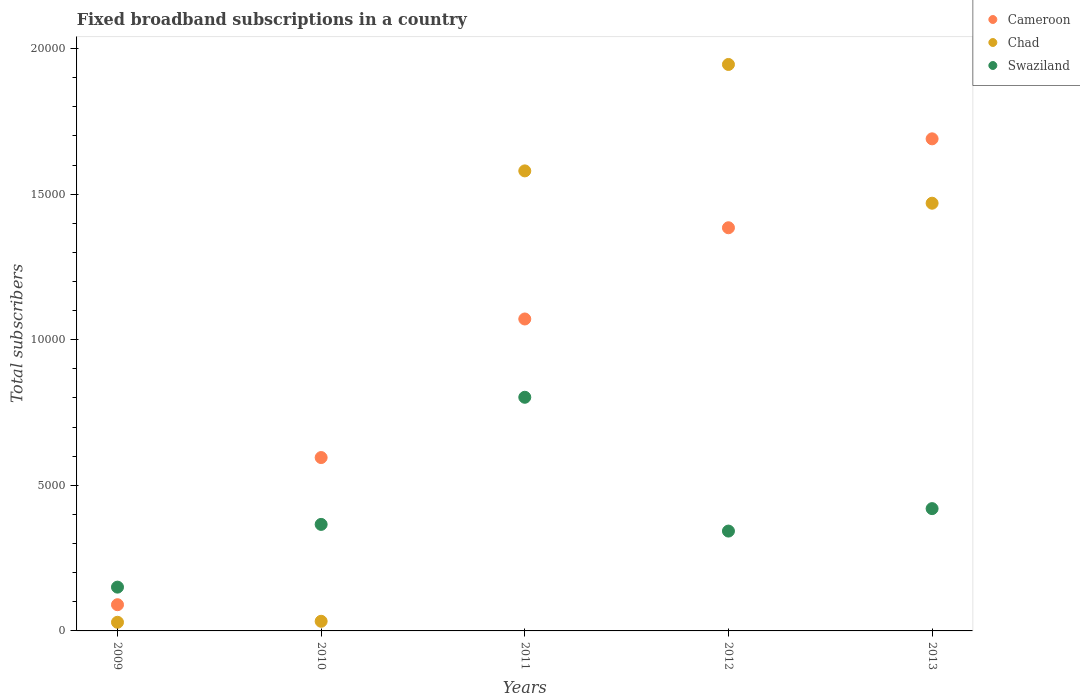How many different coloured dotlines are there?
Your response must be concise. 3. What is the number of broadband subscriptions in Swaziland in 2010?
Provide a succinct answer. 3658. Across all years, what is the maximum number of broadband subscriptions in Cameroon?
Make the answer very short. 1.69e+04. Across all years, what is the minimum number of broadband subscriptions in Chad?
Your response must be concise. 297. What is the total number of broadband subscriptions in Cameroon in the graph?
Keep it short and to the point. 4.83e+04. What is the difference between the number of broadband subscriptions in Swaziland in 2009 and that in 2013?
Provide a short and direct response. -2696. What is the difference between the number of broadband subscriptions in Chad in 2009 and the number of broadband subscriptions in Swaziland in 2012?
Offer a terse response. -3132. What is the average number of broadband subscriptions in Chad per year?
Offer a terse response. 1.01e+04. In the year 2011, what is the difference between the number of broadband subscriptions in Chad and number of broadband subscriptions in Swaziland?
Give a very brief answer. 7775. What is the ratio of the number of broadband subscriptions in Cameroon in 2011 to that in 2013?
Provide a succinct answer. 0.63. Is the number of broadband subscriptions in Swaziland in 2009 less than that in 2012?
Offer a terse response. Yes. What is the difference between the highest and the second highest number of broadband subscriptions in Swaziland?
Make the answer very short. 3824. What is the difference between the highest and the lowest number of broadband subscriptions in Cameroon?
Your answer should be very brief. 1.60e+04. In how many years, is the number of broadband subscriptions in Chad greater than the average number of broadband subscriptions in Chad taken over all years?
Offer a very short reply. 3. Is the sum of the number of broadband subscriptions in Cameroon in 2010 and 2013 greater than the maximum number of broadband subscriptions in Chad across all years?
Offer a terse response. Yes. Is it the case that in every year, the sum of the number of broadband subscriptions in Chad and number of broadband subscriptions in Cameroon  is greater than the number of broadband subscriptions in Swaziland?
Provide a short and direct response. No. Is the number of broadband subscriptions in Cameroon strictly greater than the number of broadband subscriptions in Chad over the years?
Offer a terse response. No. Is the number of broadband subscriptions in Chad strictly less than the number of broadband subscriptions in Swaziland over the years?
Make the answer very short. No. How many dotlines are there?
Offer a very short reply. 3. How many years are there in the graph?
Your answer should be compact. 5. Are the values on the major ticks of Y-axis written in scientific E-notation?
Give a very brief answer. No. Does the graph contain any zero values?
Provide a succinct answer. No. Does the graph contain grids?
Ensure brevity in your answer.  No. Where does the legend appear in the graph?
Your response must be concise. Top right. How many legend labels are there?
Ensure brevity in your answer.  3. What is the title of the graph?
Your answer should be compact. Fixed broadband subscriptions in a country. Does "Kosovo" appear as one of the legend labels in the graph?
Your response must be concise. No. What is the label or title of the X-axis?
Provide a short and direct response. Years. What is the label or title of the Y-axis?
Give a very brief answer. Total subscribers. What is the Total subscribers in Cameroon in 2009?
Offer a very short reply. 900. What is the Total subscribers of Chad in 2009?
Offer a terse response. 297. What is the Total subscribers of Swaziland in 2009?
Offer a very short reply. 1504. What is the Total subscribers of Cameroon in 2010?
Give a very brief answer. 5954. What is the Total subscribers in Chad in 2010?
Give a very brief answer. 331. What is the Total subscribers in Swaziland in 2010?
Provide a succinct answer. 3658. What is the Total subscribers of Cameroon in 2011?
Provide a short and direct response. 1.07e+04. What is the Total subscribers in Chad in 2011?
Provide a short and direct response. 1.58e+04. What is the Total subscribers in Swaziland in 2011?
Give a very brief answer. 8024. What is the Total subscribers in Cameroon in 2012?
Keep it short and to the point. 1.38e+04. What is the Total subscribers of Chad in 2012?
Your response must be concise. 1.95e+04. What is the Total subscribers in Swaziland in 2012?
Your response must be concise. 3429. What is the Total subscribers in Cameroon in 2013?
Make the answer very short. 1.69e+04. What is the Total subscribers in Chad in 2013?
Offer a very short reply. 1.47e+04. What is the Total subscribers of Swaziland in 2013?
Give a very brief answer. 4200. Across all years, what is the maximum Total subscribers of Cameroon?
Ensure brevity in your answer.  1.69e+04. Across all years, what is the maximum Total subscribers of Chad?
Give a very brief answer. 1.95e+04. Across all years, what is the maximum Total subscribers of Swaziland?
Provide a succinct answer. 8024. Across all years, what is the minimum Total subscribers of Cameroon?
Keep it short and to the point. 900. Across all years, what is the minimum Total subscribers in Chad?
Make the answer very short. 297. Across all years, what is the minimum Total subscribers in Swaziland?
Offer a terse response. 1504. What is the total Total subscribers of Cameroon in the graph?
Offer a terse response. 4.83e+04. What is the total Total subscribers of Chad in the graph?
Provide a short and direct response. 5.06e+04. What is the total Total subscribers of Swaziland in the graph?
Provide a short and direct response. 2.08e+04. What is the difference between the Total subscribers of Cameroon in 2009 and that in 2010?
Your answer should be very brief. -5054. What is the difference between the Total subscribers in Chad in 2009 and that in 2010?
Your answer should be compact. -34. What is the difference between the Total subscribers of Swaziland in 2009 and that in 2010?
Your response must be concise. -2154. What is the difference between the Total subscribers in Cameroon in 2009 and that in 2011?
Your response must be concise. -9813. What is the difference between the Total subscribers of Chad in 2009 and that in 2011?
Offer a terse response. -1.55e+04. What is the difference between the Total subscribers in Swaziland in 2009 and that in 2011?
Ensure brevity in your answer.  -6520. What is the difference between the Total subscribers in Cameroon in 2009 and that in 2012?
Your response must be concise. -1.29e+04. What is the difference between the Total subscribers in Chad in 2009 and that in 2012?
Your response must be concise. -1.92e+04. What is the difference between the Total subscribers in Swaziland in 2009 and that in 2012?
Make the answer very short. -1925. What is the difference between the Total subscribers of Cameroon in 2009 and that in 2013?
Offer a terse response. -1.60e+04. What is the difference between the Total subscribers of Chad in 2009 and that in 2013?
Ensure brevity in your answer.  -1.44e+04. What is the difference between the Total subscribers of Swaziland in 2009 and that in 2013?
Provide a succinct answer. -2696. What is the difference between the Total subscribers in Cameroon in 2010 and that in 2011?
Provide a succinct answer. -4759. What is the difference between the Total subscribers of Chad in 2010 and that in 2011?
Make the answer very short. -1.55e+04. What is the difference between the Total subscribers of Swaziland in 2010 and that in 2011?
Provide a succinct answer. -4366. What is the difference between the Total subscribers in Cameroon in 2010 and that in 2012?
Your response must be concise. -7892. What is the difference between the Total subscribers of Chad in 2010 and that in 2012?
Your answer should be compact. -1.91e+04. What is the difference between the Total subscribers of Swaziland in 2010 and that in 2012?
Offer a very short reply. 229. What is the difference between the Total subscribers of Cameroon in 2010 and that in 2013?
Provide a short and direct response. -1.09e+04. What is the difference between the Total subscribers of Chad in 2010 and that in 2013?
Offer a very short reply. -1.44e+04. What is the difference between the Total subscribers of Swaziland in 2010 and that in 2013?
Offer a terse response. -542. What is the difference between the Total subscribers in Cameroon in 2011 and that in 2012?
Provide a succinct answer. -3133. What is the difference between the Total subscribers of Chad in 2011 and that in 2012?
Offer a terse response. -3655. What is the difference between the Total subscribers in Swaziland in 2011 and that in 2012?
Make the answer very short. 4595. What is the difference between the Total subscribers in Cameroon in 2011 and that in 2013?
Your answer should be compact. -6187. What is the difference between the Total subscribers of Chad in 2011 and that in 2013?
Your answer should be compact. 1110. What is the difference between the Total subscribers in Swaziland in 2011 and that in 2013?
Your response must be concise. 3824. What is the difference between the Total subscribers of Cameroon in 2012 and that in 2013?
Your answer should be compact. -3054. What is the difference between the Total subscribers of Chad in 2012 and that in 2013?
Your response must be concise. 4765. What is the difference between the Total subscribers of Swaziland in 2012 and that in 2013?
Keep it short and to the point. -771. What is the difference between the Total subscribers of Cameroon in 2009 and the Total subscribers of Chad in 2010?
Give a very brief answer. 569. What is the difference between the Total subscribers of Cameroon in 2009 and the Total subscribers of Swaziland in 2010?
Your answer should be very brief. -2758. What is the difference between the Total subscribers of Chad in 2009 and the Total subscribers of Swaziland in 2010?
Ensure brevity in your answer.  -3361. What is the difference between the Total subscribers of Cameroon in 2009 and the Total subscribers of Chad in 2011?
Ensure brevity in your answer.  -1.49e+04. What is the difference between the Total subscribers in Cameroon in 2009 and the Total subscribers in Swaziland in 2011?
Give a very brief answer. -7124. What is the difference between the Total subscribers of Chad in 2009 and the Total subscribers of Swaziland in 2011?
Your response must be concise. -7727. What is the difference between the Total subscribers in Cameroon in 2009 and the Total subscribers in Chad in 2012?
Your response must be concise. -1.86e+04. What is the difference between the Total subscribers of Cameroon in 2009 and the Total subscribers of Swaziland in 2012?
Provide a succinct answer. -2529. What is the difference between the Total subscribers of Chad in 2009 and the Total subscribers of Swaziland in 2012?
Your answer should be compact. -3132. What is the difference between the Total subscribers in Cameroon in 2009 and the Total subscribers in Chad in 2013?
Offer a very short reply. -1.38e+04. What is the difference between the Total subscribers in Cameroon in 2009 and the Total subscribers in Swaziland in 2013?
Offer a very short reply. -3300. What is the difference between the Total subscribers of Chad in 2009 and the Total subscribers of Swaziland in 2013?
Your response must be concise. -3903. What is the difference between the Total subscribers in Cameroon in 2010 and the Total subscribers in Chad in 2011?
Give a very brief answer. -9845. What is the difference between the Total subscribers in Cameroon in 2010 and the Total subscribers in Swaziland in 2011?
Provide a short and direct response. -2070. What is the difference between the Total subscribers in Chad in 2010 and the Total subscribers in Swaziland in 2011?
Keep it short and to the point. -7693. What is the difference between the Total subscribers in Cameroon in 2010 and the Total subscribers in Chad in 2012?
Offer a very short reply. -1.35e+04. What is the difference between the Total subscribers in Cameroon in 2010 and the Total subscribers in Swaziland in 2012?
Provide a short and direct response. 2525. What is the difference between the Total subscribers of Chad in 2010 and the Total subscribers of Swaziland in 2012?
Give a very brief answer. -3098. What is the difference between the Total subscribers in Cameroon in 2010 and the Total subscribers in Chad in 2013?
Your response must be concise. -8735. What is the difference between the Total subscribers of Cameroon in 2010 and the Total subscribers of Swaziland in 2013?
Your answer should be very brief. 1754. What is the difference between the Total subscribers of Chad in 2010 and the Total subscribers of Swaziland in 2013?
Make the answer very short. -3869. What is the difference between the Total subscribers in Cameroon in 2011 and the Total subscribers in Chad in 2012?
Provide a short and direct response. -8741. What is the difference between the Total subscribers of Cameroon in 2011 and the Total subscribers of Swaziland in 2012?
Ensure brevity in your answer.  7284. What is the difference between the Total subscribers of Chad in 2011 and the Total subscribers of Swaziland in 2012?
Ensure brevity in your answer.  1.24e+04. What is the difference between the Total subscribers of Cameroon in 2011 and the Total subscribers of Chad in 2013?
Give a very brief answer. -3976. What is the difference between the Total subscribers of Cameroon in 2011 and the Total subscribers of Swaziland in 2013?
Your answer should be compact. 6513. What is the difference between the Total subscribers in Chad in 2011 and the Total subscribers in Swaziland in 2013?
Offer a very short reply. 1.16e+04. What is the difference between the Total subscribers in Cameroon in 2012 and the Total subscribers in Chad in 2013?
Offer a terse response. -843. What is the difference between the Total subscribers of Cameroon in 2012 and the Total subscribers of Swaziland in 2013?
Offer a terse response. 9646. What is the difference between the Total subscribers in Chad in 2012 and the Total subscribers in Swaziland in 2013?
Provide a short and direct response. 1.53e+04. What is the average Total subscribers of Cameroon per year?
Make the answer very short. 9662.6. What is the average Total subscribers of Chad per year?
Keep it short and to the point. 1.01e+04. What is the average Total subscribers of Swaziland per year?
Provide a short and direct response. 4163. In the year 2009, what is the difference between the Total subscribers in Cameroon and Total subscribers in Chad?
Offer a terse response. 603. In the year 2009, what is the difference between the Total subscribers of Cameroon and Total subscribers of Swaziland?
Ensure brevity in your answer.  -604. In the year 2009, what is the difference between the Total subscribers in Chad and Total subscribers in Swaziland?
Provide a succinct answer. -1207. In the year 2010, what is the difference between the Total subscribers in Cameroon and Total subscribers in Chad?
Your answer should be very brief. 5623. In the year 2010, what is the difference between the Total subscribers in Cameroon and Total subscribers in Swaziland?
Provide a short and direct response. 2296. In the year 2010, what is the difference between the Total subscribers of Chad and Total subscribers of Swaziland?
Provide a short and direct response. -3327. In the year 2011, what is the difference between the Total subscribers in Cameroon and Total subscribers in Chad?
Offer a terse response. -5086. In the year 2011, what is the difference between the Total subscribers of Cameroon and Total subscribers of Swaziland?
Ensure brevity in your answer.  2689. In the year 2011, what is the difference between the Total subscribers in Chad and Total subscribers in Swaziland?
Keep it short and to the point. 7775. In the year 2012, what is the difference between the Total subscribers in Cameroon and Total subscribers in Chad?
Make the answer very short. -5608. In the year 2012, what is the difference between the Total subscribers of Cameroon and Total subscribers of Swaziland?
Provide a succinct answer. 1.04e+04. In the year 2012, what is the difference between the Total subscribers in Chad and Total subscribers in Swaziland?
Make the answer very short. 1.60e+04. In the year 2013, what is the difference between the Total subscribers of Cameroon and Total subscribers of Chad?
Your answer should be compact. 2211. In the year 2013, what is the difference between the Total subscribers of Cameroon and Total subscribers of Swaziland?
Your answer should be very brief. 1.27e+04. In the year 2013, what is the difference between the Total subscribers of Chad and Total subscribers of Swaziland?
Your answer should be very brief. 1.05e+04. What is the ratio of the Total subscribers of Cameroon in 2009 to that in 2010?
Ensure brevity in your answer.  0.15. What is the ratio of the Total subscribers of Chad in 2009 to that in 2010?
Give a very brief answer. 0.9. What is the ratio of the Total subscribers of Swaziland in 2009 to that in 2010?
Keep it short and to the point. 0.41. What is the ratio of the Total subscribers of Cameroon in 2009 to that in 2011?
Keep it short and to the point. 0.08. What is the ratio of the Total subscribers in Chad in 2009 to that in 2011?
Offer a terse response. 0.02. What is the ratio of the Total subscribers of Swaziland in 2009 to that in 2011?
Give a very brief answer. 0.19. What is the ratio of the Total subscribers of Cameroon in 2009 to that in 2012?
Give a very brief answer. 0.07. What is the ratio of the Total subscribers in Chad in 2009 to that in 2012?
Make the answer very short. 0.02. What is the ratio of the Total subscribers of Swaziland in 2009 to that in 2012?
Provide a short and direct response. 0.44. What is the ratio of the Total subscribers of Cameroon in 2009 to that in 2013?
Offer a terse response. 0.05. What is the ratio of the Total subscribers in Chad in 2009 to that in 2013?
Keep it short and to the point. 0.02. What is the ratio of the Total subscribers in Swaziland in 2009 to that in 2013?
Keep it short and to the point. 0.36. What is the ratio of the Total subscribers of Cameroon in 2010 to that in 2011?
Provide a short and direct response. 0.56. What is the ratio of the Total subscribers in Chad in 2010 to that in 2011?
Ensure brevity in your answer.  0.02. What is the ratio of the Total subscribers in Swaziland in 2010 to that in 2011?
Make the answer very short. 0.46. What is the ratio of the Total subscribers of Cameroon in 2010 to that in 2012?
Ensure brevity in your answer.  0.43. What is the ratio of the Total subscribers of Chad in 2010 to that in 2012?
Ensure brevity in your answer.  0.02. What is the ratio of the Total subscribers of Swaziland in 2010 to that in 2012?
Provide a succinct answer. 1.07. What is the ratio of the Total subscribers in Cameroon in 2010 to that in 2013?
Provide a succinct answer. 0.35. What is the ratio of the Total subscribers of Chad in 2010 to that in 2013?
Your response must be concise. 0.02. What is the ratio of the Total subscribers in Swaziland in 2010 to that in 2013?
Provide a succinct answer. 0.87. What is the ratio of the Total subscribers in Cameroon in 2011 to that in 2012?
Your answer should be very brief. 0.77. What is the ratio of the Total subscribers of Chad in 2011 to that in 2012?
Keep it short and to the point. 0.81. What is the ratio of the Total subscribers of Swaziland in 2011 to that in 2012?
Make the answer very short. 2.34. What is the ratio of the Total subscribers in Cameroon in 2011 to that in 2013?
Your response must be concise. 0.63. What is the ratio of the Total subscribers of Chad in 2011 to that in 2013?
Provide a succinct answer. 1.08. What is the ratio of the Total subscribers of Swaziland in 2011 to that in 2013?
Keep it short and to the point. 1.91. What is the ratio of the Total subscribers in Cameroon in 2012 to that in 2013?
Provide a short and direct response. 0.82. What is the ratio of the Total subscribers in Chad in 2012 to that in 2013?
Your answer should be compact. 1.32. What is the ratio of the Total subscribers of Swaziland in 2012 to that in 2013?
Your response must be concise. 0.82. What is the difference between the highest and the second highest Total subscribers in Cameroon?
Your response must be concise. 3054. What is the difference between the highest and the second highest Total subscribers of Chad?
Ensure brevity in your answer.  3655. What is the difference between the highest and the second highest Total subscribers in Swaziland?
Your response must be concise. 3824. What is the difference between the highest and the lowest Total subscribers of Cameroon?
Your response must be concise. 1.60e+04. What is the difference between the highest and the lowest Total subscribers in Chad?
Keep it short and to the point. 1.92e+04. What is the difference between the highest and the lowest Total subscribers of Swaziland?
Provide a short and direct response. 6520. 